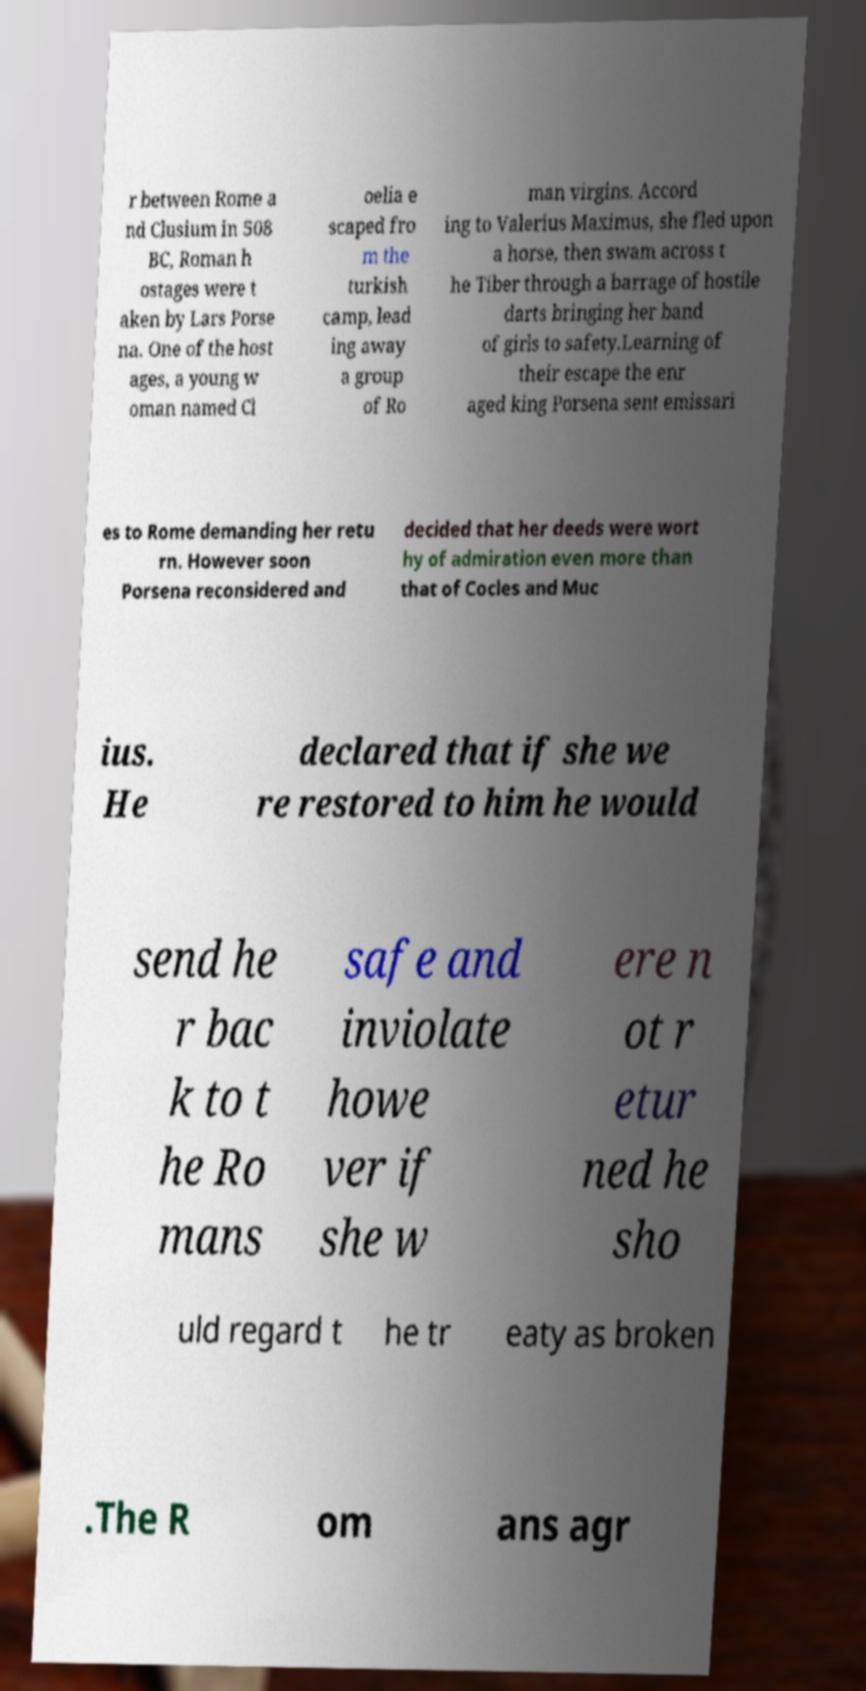Can you accurately transcribe the text from the provided image for me? r between Rome a nd Clusium in 508 BC, Roman h ostages were t aken by Lars Porse na. One of the host ages, a young w oman named Cl oelia e scaped fro m the turkish camp, lead ing away a group of Ro man virgins. Accord ing to Valerius Maximus, she fled upon a horse, then swam across t he Tiber through a barrage of hostile darts bringing her band of girls to safety.Learning of their escape the enr aged king Porsena sent emissari es to Rome demanding her retu rn. However soon Porsena reconsidered and decided that her deeds were wort hy of admiration even more than that of Cocles and Muc ius. He declared that if she we re restored to him he would send he r bac k to t he Ro mans safe and inviolate howe ver if she w ere n ot r etur ned he sho uld regard t he tr eaty as broken .The R om ans agr 